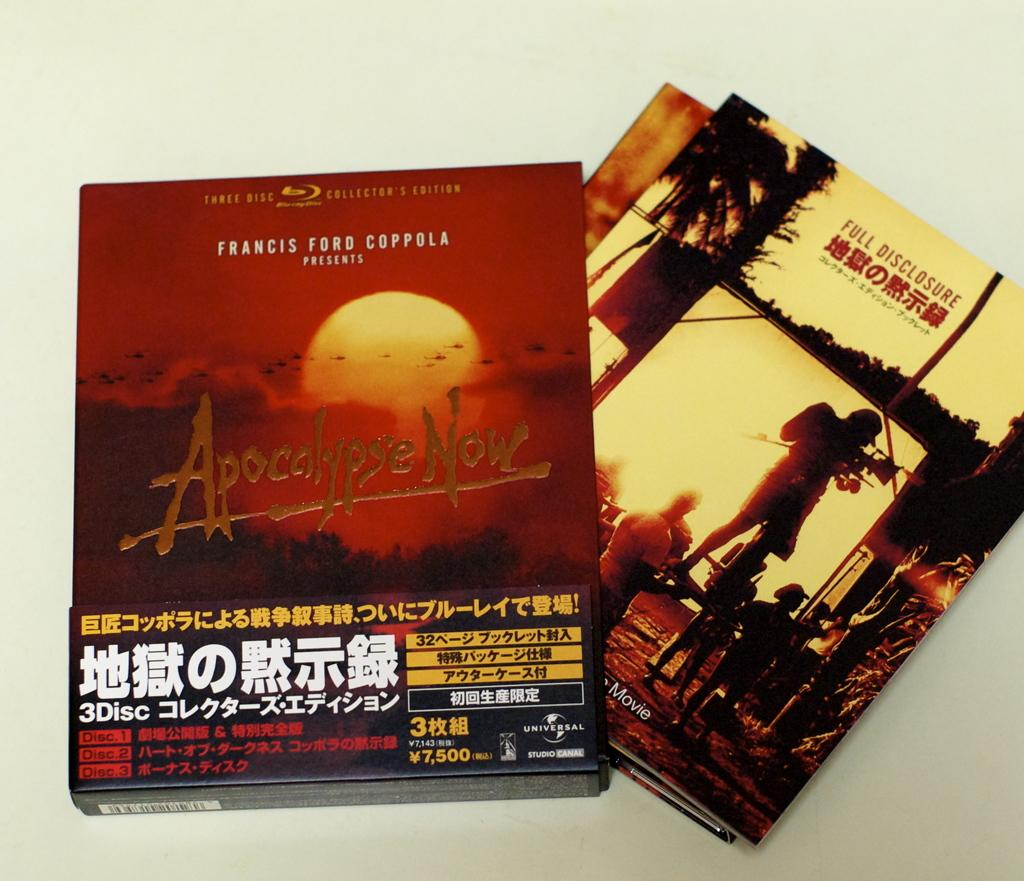<image>
Render a clear and concise summary of the photo. A CD cover for the movie Apocolypse Now by Francis Coppola. 